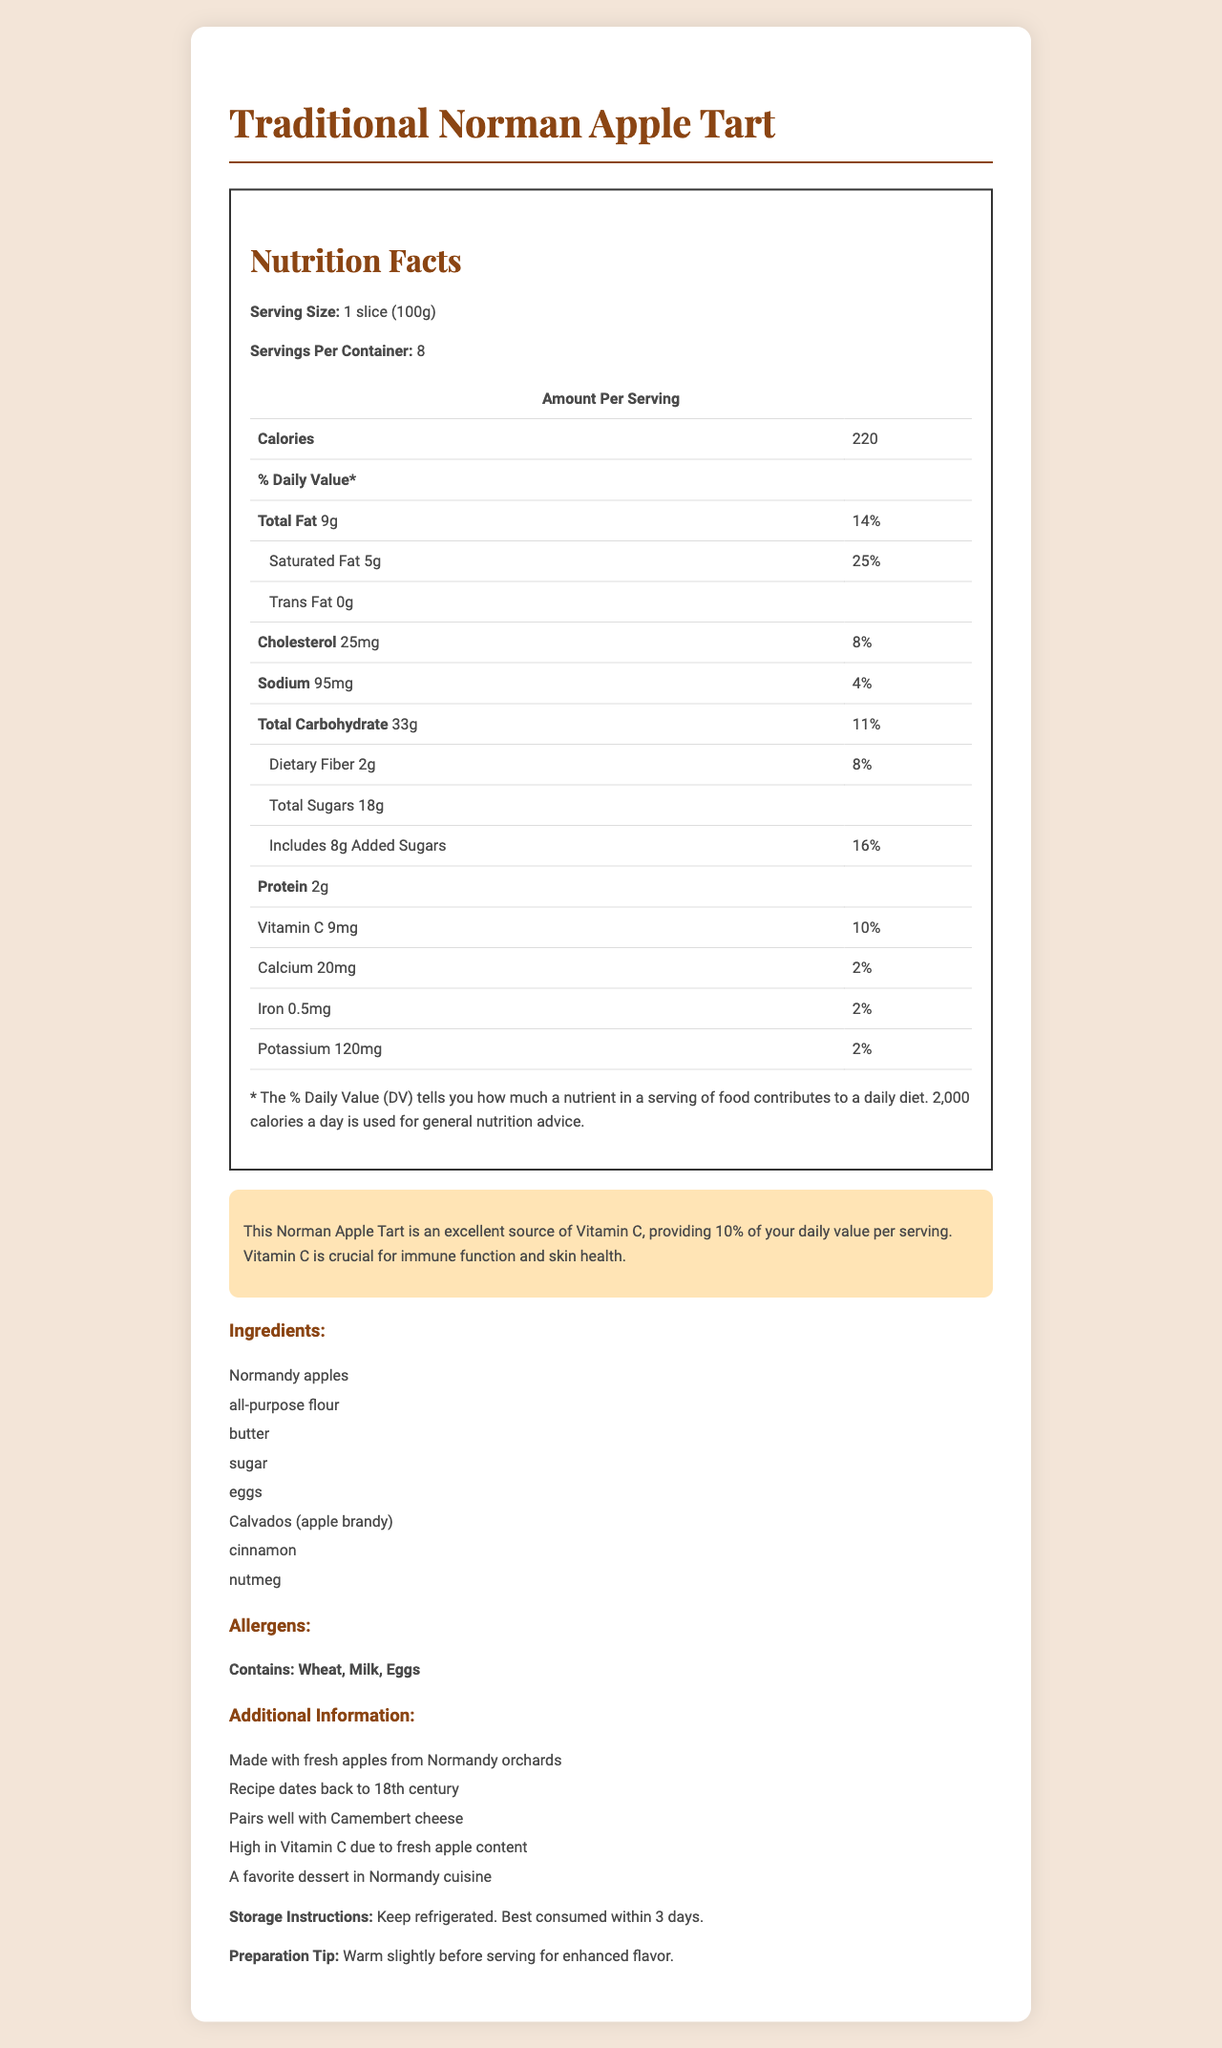what is the serving size of the Traditional Norman Apple Tart? According to the Nutrition Facts label, the serving size is listed as 1 slice (100g).
Answer: 1 slice (100g) What percentage of the daily value of Vitamin C does one serving of the tart provide? The label indicates that one serving offers 10% of the daily value for Vitamin C.
Answer: 10% How many servings are there in each container? The document states that there are 8 servings per container.
Answer: 8 Which ingredient gives the tart its unique flavor? Calvados, an apple brandy, is one of the ingredients listed, giving the tart its unique flavor.
Answer: Calvados (apple brandy) How many grams of saturated fat are in one serving? The Nutrition Facts label shows that one serving contains 5 grams of saturated fat.
Answer: 5g What is the total amount of sugars in one serving? The label specifies that there are 18 grams of total sugars in one serving of the tart.
Answer: 18g What is the main nutritional highlight of the Traditional Norman Apple Tart? The document highlights that the tart is an excellent source of Vitamin C, providing 10% of the daily value per serving.
Answer: High in Vitamin C Which of the following is NOT an ingredient in the tart? A. Normandy apples B. Cinnamon C. Almonds D. Nutmeg The ingredients list does not mention almonds; Normandy apples, cinnamon, and nutmeg are included.
Answer: C. Almonds What should you do to enhance the flavor of the tart before serving? A. Serve with wine B. Add extra sugar C. Warm slightly D. Sprinkle with cheese The preparation tip mentions that you should warm the tart slightly before serving for enhanced flavor.
Answer: C. Warm slightly Is the tart high in cholesterol? Yes/No The tart contains 25 milligrams of cholesterol per serving, which is not considered high; typically, 300 milligrams per day is the recommended limit.
Answer: No Summarize the main idea of the document. This document gives a comprehensive overview of the Traditional Norman Apple Tart, emphasizing its nutrition facts, high Vitamin C content due to its fresh Normandy apples, and other related details.
Answer: The document provides detailed nutritional information about the Traditional Norman Apple Tart, including its ingredients, allergens, and notable nutritional highlights. It showcases the tart as a high source of Vitamin C and offers tips on preparation and storage. Is this tart gluten-free? The ingredients list includes all-purpose flour, which contains gluten, so the tart is not gluten-free.
Answer: No Why is this tart considered a favorite dessert in Normandy cuisine? The additional information section notes that the recipe dates back to the 18th century and is made with fresh Normandy apples, contributing to its status as a favorite dessert in Normandy cuisine.
Answer: Due to its traditional recipe and local ingredients like fresh Normandy apples and Calvados 